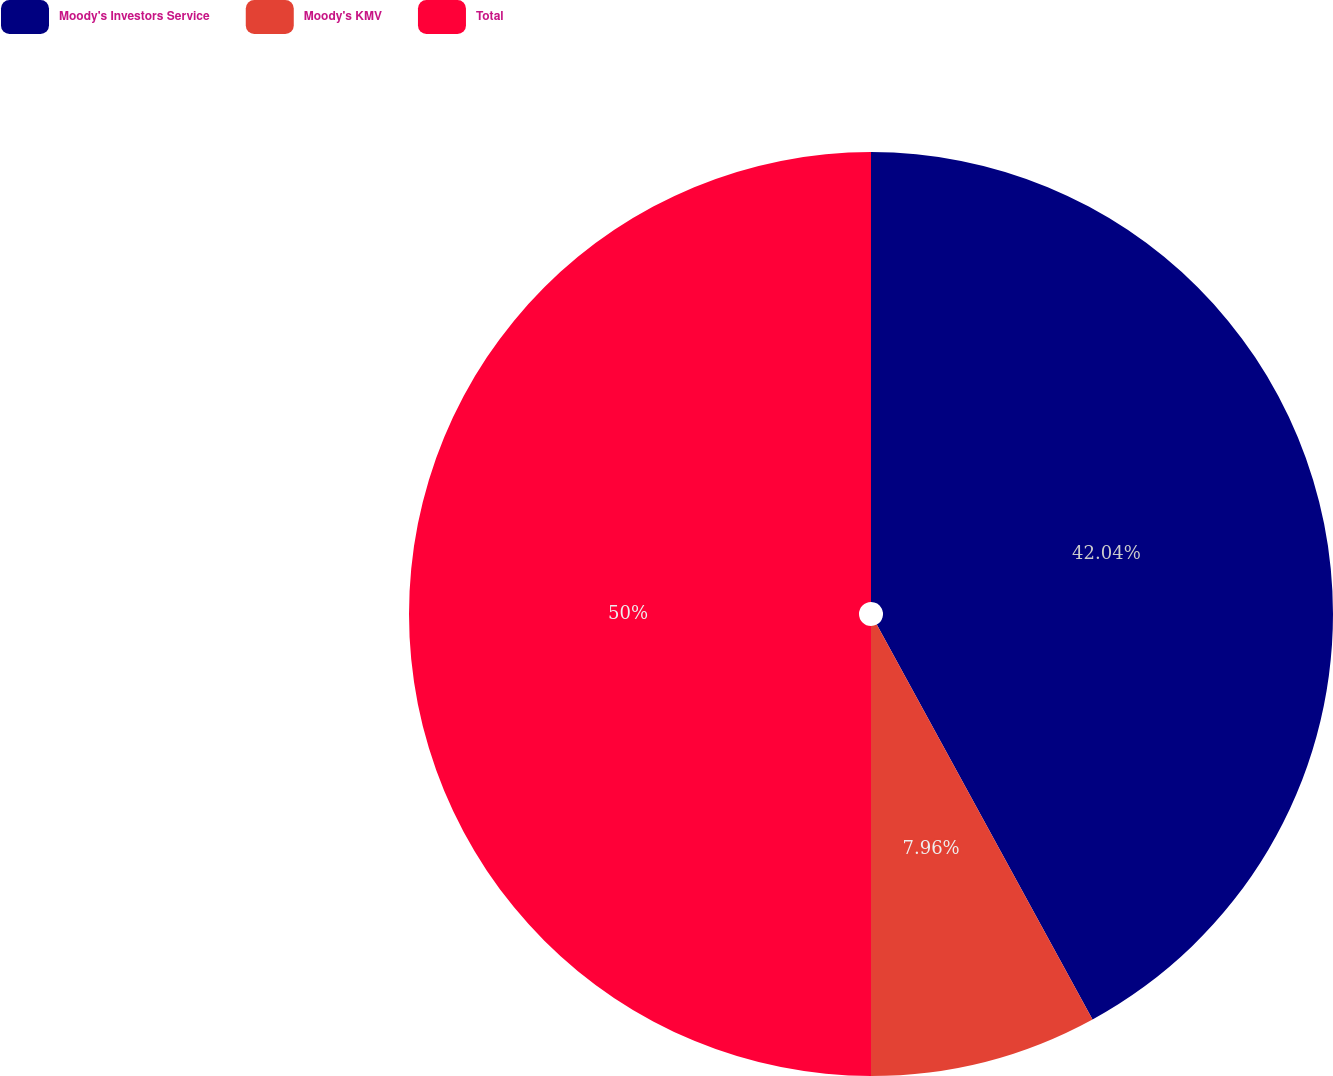<chart> <loc_0><loc_0><loc_500><loc_500><pie_chart><fcel>Moody's Investors Service<fcel>Moody's KMV<fcel>Total<nl><fcel>42.04%<fcel>7.96%<fcel>50.0%<nl></chart> 